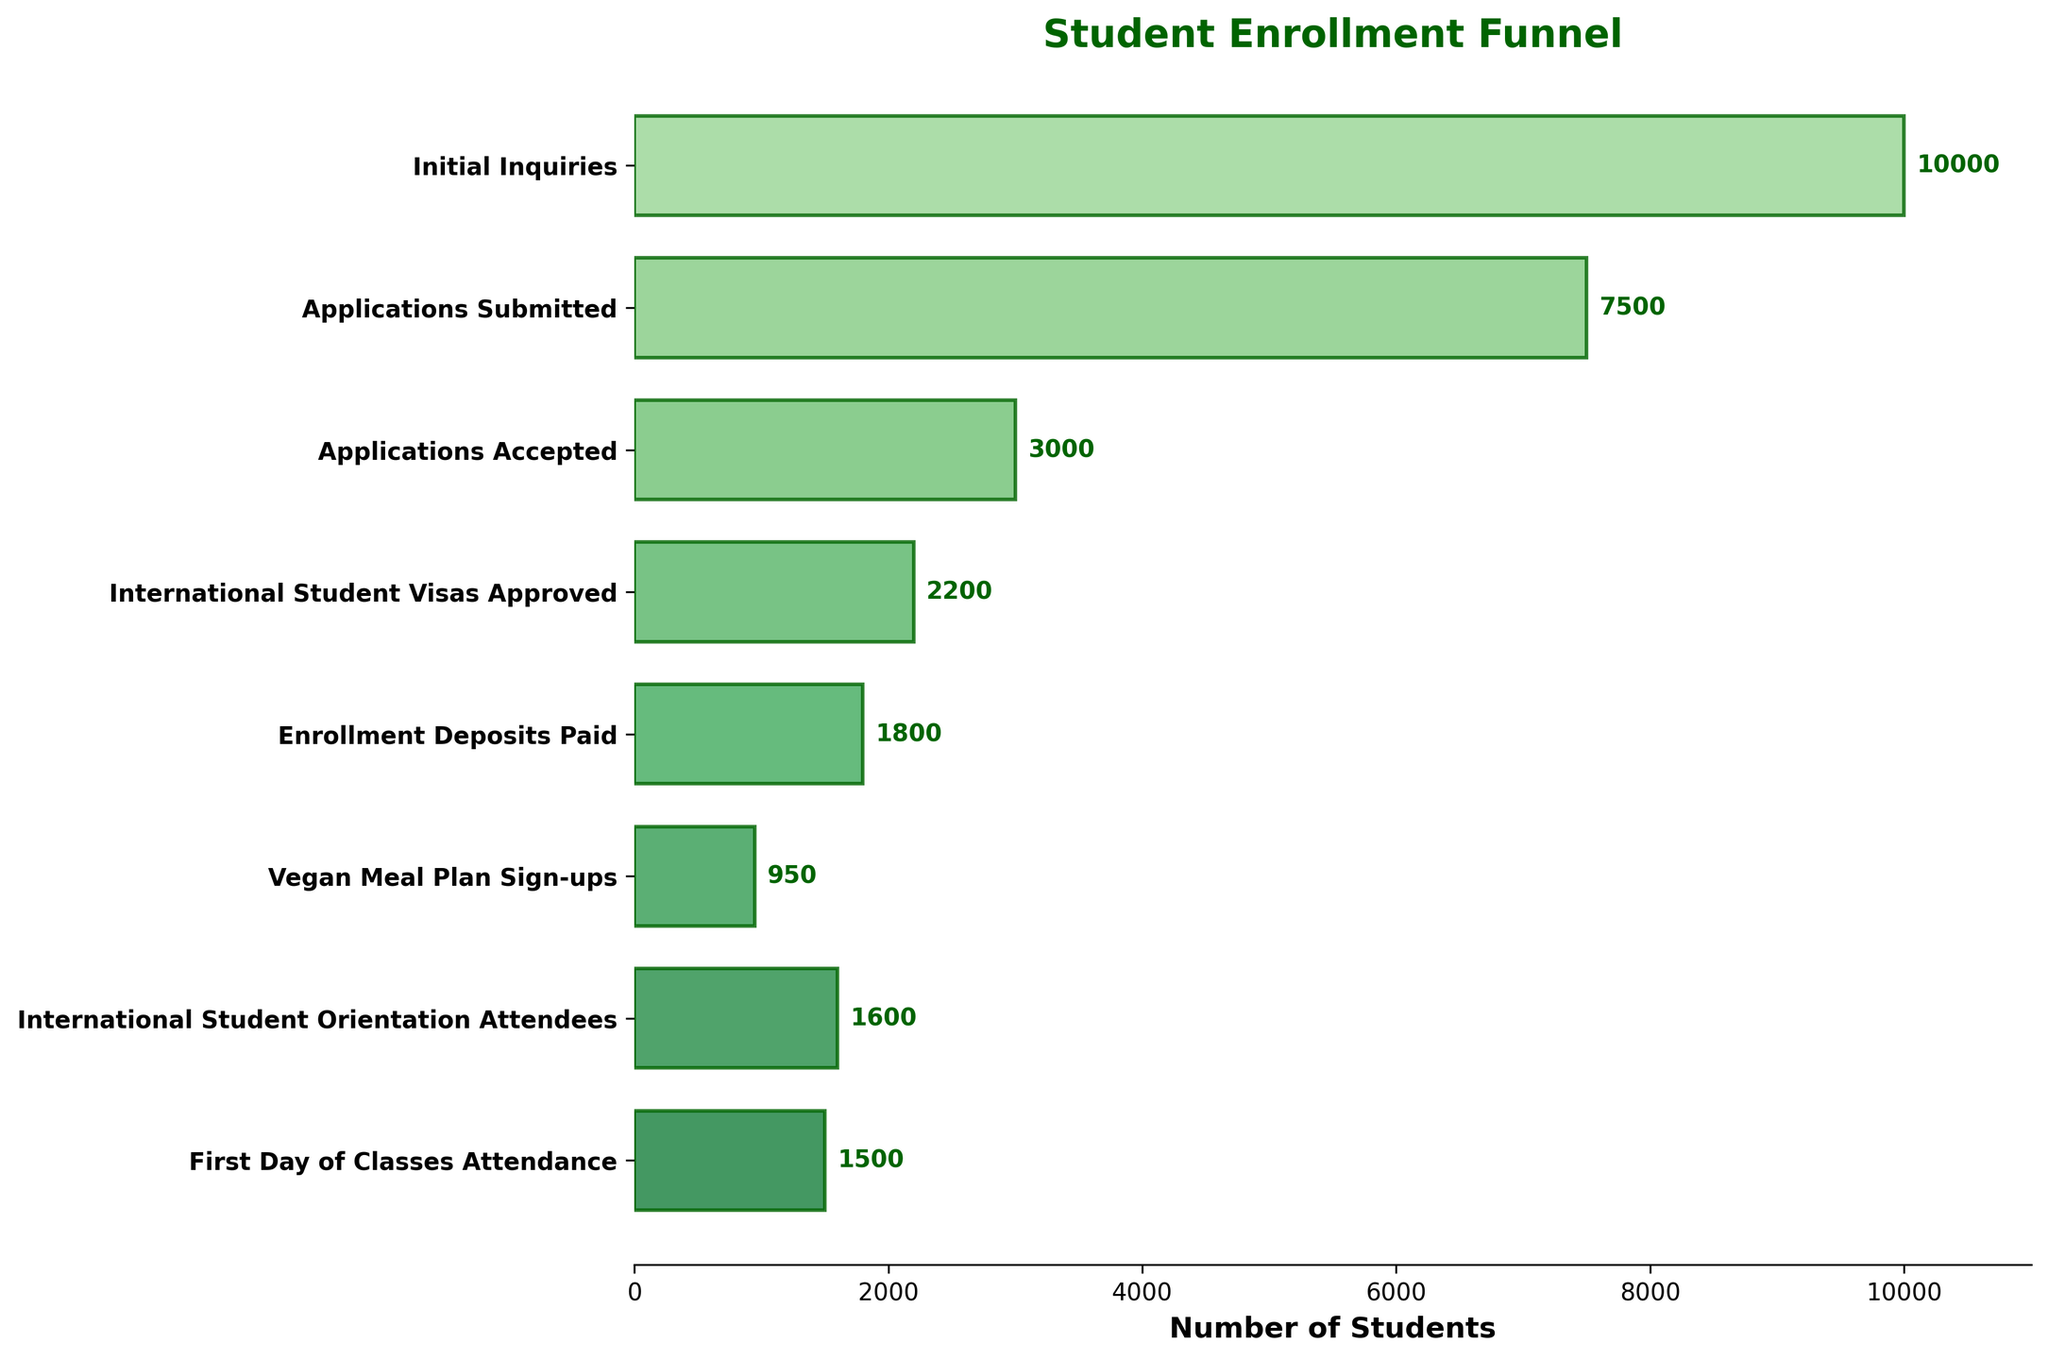How many students signed up for the vegan meal plan? Look at the bar labeled "Vegan Meal Plan Sign-ups" and read the numerical value displayed next to the corresponding bar
Answer: 950 Which enrollment stage had the highest number of students? Identify the bar with the greatest length and refer to its corresponding label, which represents the enrollment stage
Answer: Initial Inquiries How many students brought enrollment deposits compared to the number of initial inquiries? Subtract the number of students who paid enrollment deposits (1800) from the initial inquiries (10000) to find the difference
Answer: 8200 What is the ratio of applications accepted to applications submitted? Divide the number of accepted applications (3000) by the number of submitted applications (7500)
Answer: 0.4 How many more students attended the first day of classes than signed up for vegan meal plans? Subtract the number of vegan meal plan sign-ups (950) from the first day of classes attendance (1500)
Answer: 550 At which stage is the largest drop-off in student numbers? Determine the stage with the biggest difference between two consecutive stages by comparing the number of students moving from one stage to the next
Answer: Applications Submitted to Applications Accepted (4500 students) How many students received international student visas compared to those attending international student orientation? Subtract the number of international student visas approved (2200) from international student orientation attendees (1600) to find the difference
Answer: 600 fewer students Calculate the average number of students across all stages? Sum all the student numbers for each stage (10,000 + 7,500 + 3,000 + 2,200 + 1,800 + 950 + 1,600 + 1,500) and divide by the number of stages (8)
Answer: 3,068.75 Which stage has student enrollment closest to 2000? Identify the stage whose student number is nearest to 2000 by comparing the values of all stages
Answer: International Student Visas Approved By how much do the students attending the first day of classes exceed those paying enrollment deposits? Subtract the enrollment deposits paid (1800) from the first day of classes attendance (1500) to get the difference
Answer: 300 fewer students 